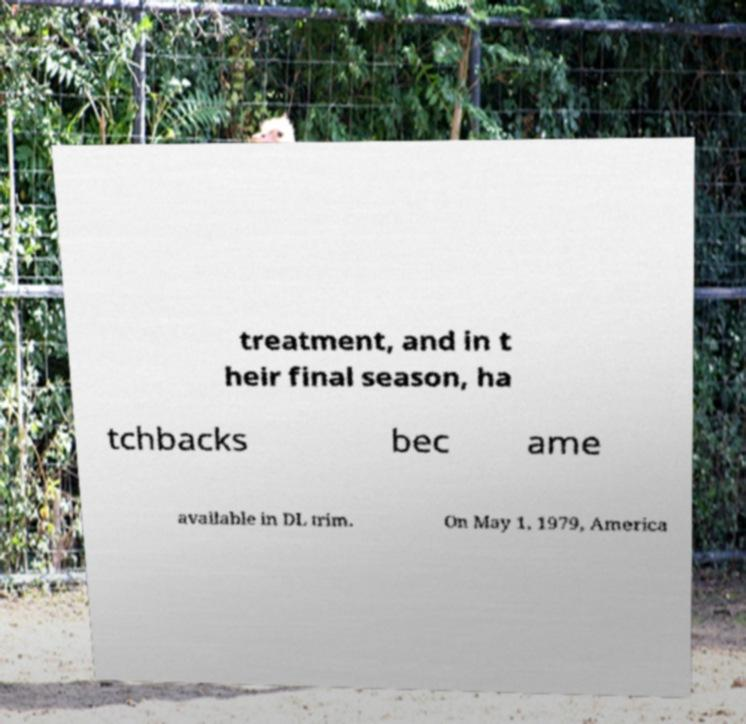Could you assist in decoding the text presented in this image and type it out clearly? treatment, and in t heir final season, ha tchbacks bec ame available in DL trim. On May 1, 1979, America 